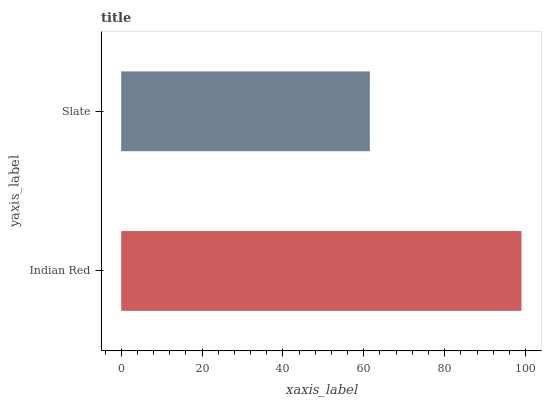Is Slate the minimum?
Answer yes or no. Yes. Is Indian Red the maximum?
Answer yes or no. Yes. Is Slate the maximum?
Answer yes or no. No. Is Indian Red greater than Slate?
Answer yes or no. Yes. Is Slate less than Indian Red?
Answer yes or no. Yes. Is Slate greater than Indian Red?
Answer yes or no. No. Is Indian Red less than Slate?
Answer yes or no. No. Is Indian Red the high median?
Answer yes or no. Yes. Is Slate the low median?
Answer yes or no. Yes. Is Slate the high median?
Answer yes or no. No. Is Indian Red the low median?
Answer yes or no. No. 